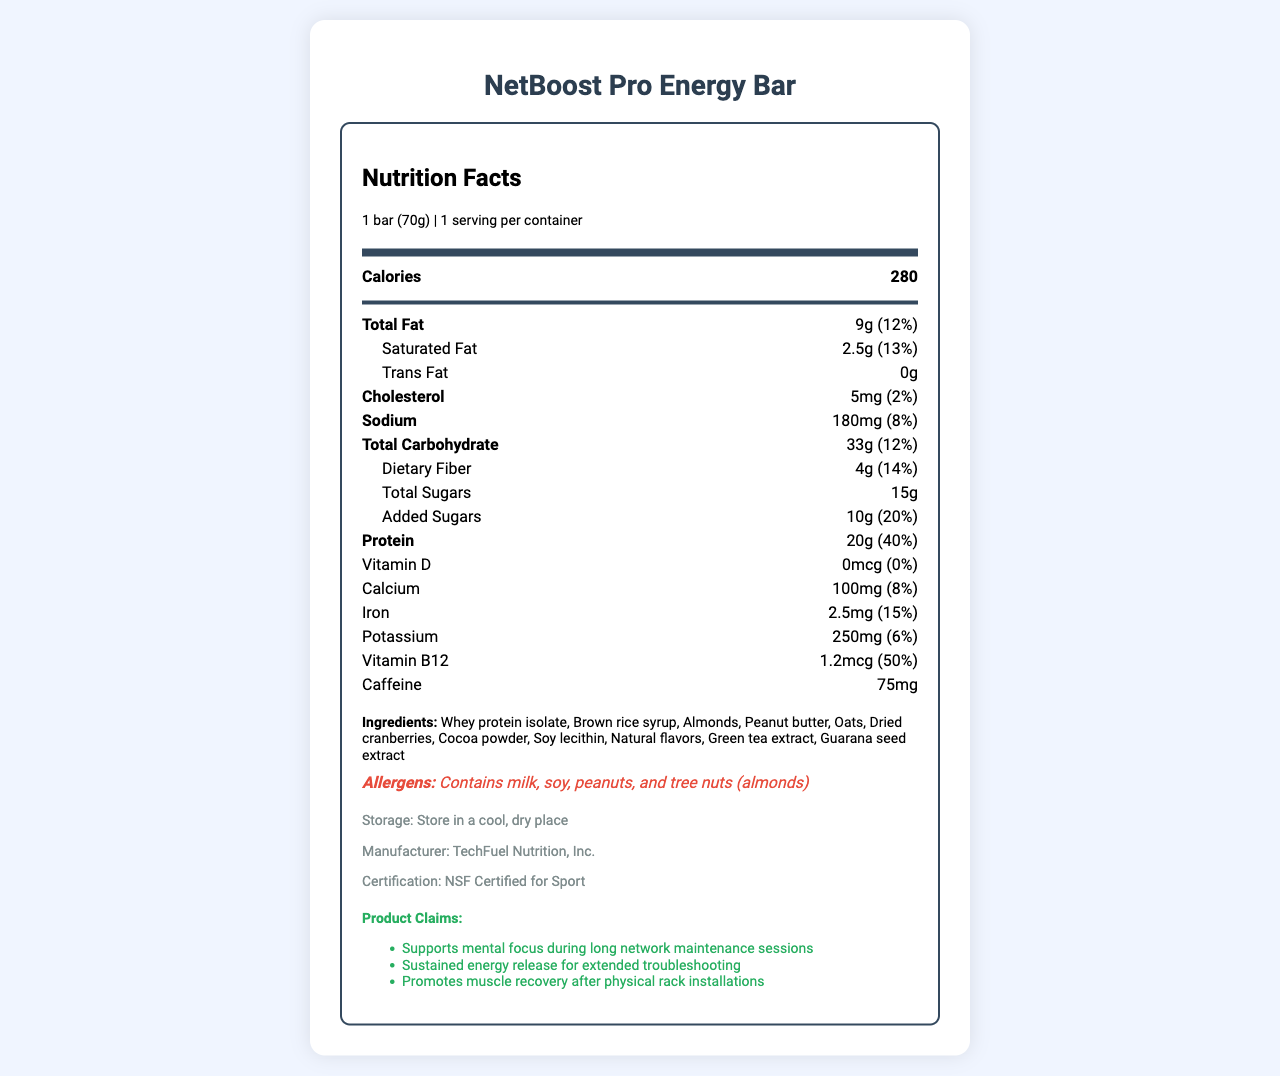what is the serving size for NetBoost Pro Energy Bar? The serving size is clearly stated under the nutrition header of the document.
Answer: 1 bar (70g) what is the amount of protein per serving? The protein content per serving is listed in the protein row in the nutrition facts table.
Answer: 20g how many calories are in one NetBoost Pro Energy Bar? The calorie content is highlighted in the main info section of the nutrition label.
Answer: 280 how much caffeine does the bar contain? The caffeine content is mentioned in the nutrient row towards the end of the nutrition label.
Answer: 75mg Is there any trans fat in the energy bar? The amount of trans fat is listed as 0g in the nutrition information.
Answer: No what company manufactures this energy bar? The manufacturer information is located in the product-info section.
Answer: TechFuel Nutrition, Inc. which ingredient is second on the list? The ingredients are listed in order of predominance, with Brown rice syrup being the second ingredient.
Answer: Brown rice syrup how much dietary fiber is in the bar? The dietary fiber amount is listed in the nutrient row along with its daily value percentage.
Answer: 4g what is the recommended storage condition for this product? The storage instructions are provided in the product-info section.
Answer: Store in a cool, dry place how many servings are in one container? A. 1 B. 2 C. 3 The servings per container are mentioned under the nutrition header.
Answer: A what percentage of the daily value for iron does the bar provide? A. 8% B. 10% C. 15% The iron content (% DV) of 15% is listed in the nutrition facts.
Answer: C Does the NetBoost Pro Energy Bar contain milk allergens? The allergens section clearly states that it contains milk along with other allergens.
Answer: Yes summarize the main nutrition claims made for the NetBoost Pro Energy Bar. These claims are listed in the product-claims section.
Answer: Supports mental focus during long network maintenance sessions, Sustained energy release for extended troubleshooting, Promotes muscle recovery after physical rack installations what is the total amount of sugars, including added sugars? The total amount can be calculated by adding total sugars (15g) and added sugars (10g), resulting in 25g.
Answer: 25g which ingredient helps with mental focus as per the claims? Though the document mentions the claims, the specific ingredient for mental focus is Green tea extract.
Answer: Green tea extract does this product have any Vitamin D? The document shows 0mcg for Vitamin D which means it does not contain any Vitamin D.
Answer: No which of the following is a nut used in the bar? A. Almonds B. Walnuts C. Pistachios Almonds are listed in the ingredients, whereas Walnuts and Pistachios are not mentioned.
Answer: A Are the claims made by the product NSF certified? The document mentions that the product is "NSF Certified for Sport" in the product-info section.
Answer: Yes what is the main idea of this document? The document mainly contains all the necessary details about the product's nutrition, ingredients, allergens, claims, and instructions.
Answer: To provide detailed nutritional and ingredient information about the NetBoost Pro Energy Bar. what is the manufacturing date of this product? The document does not provide any information about the manufacturing date.
Answer: I don't know 